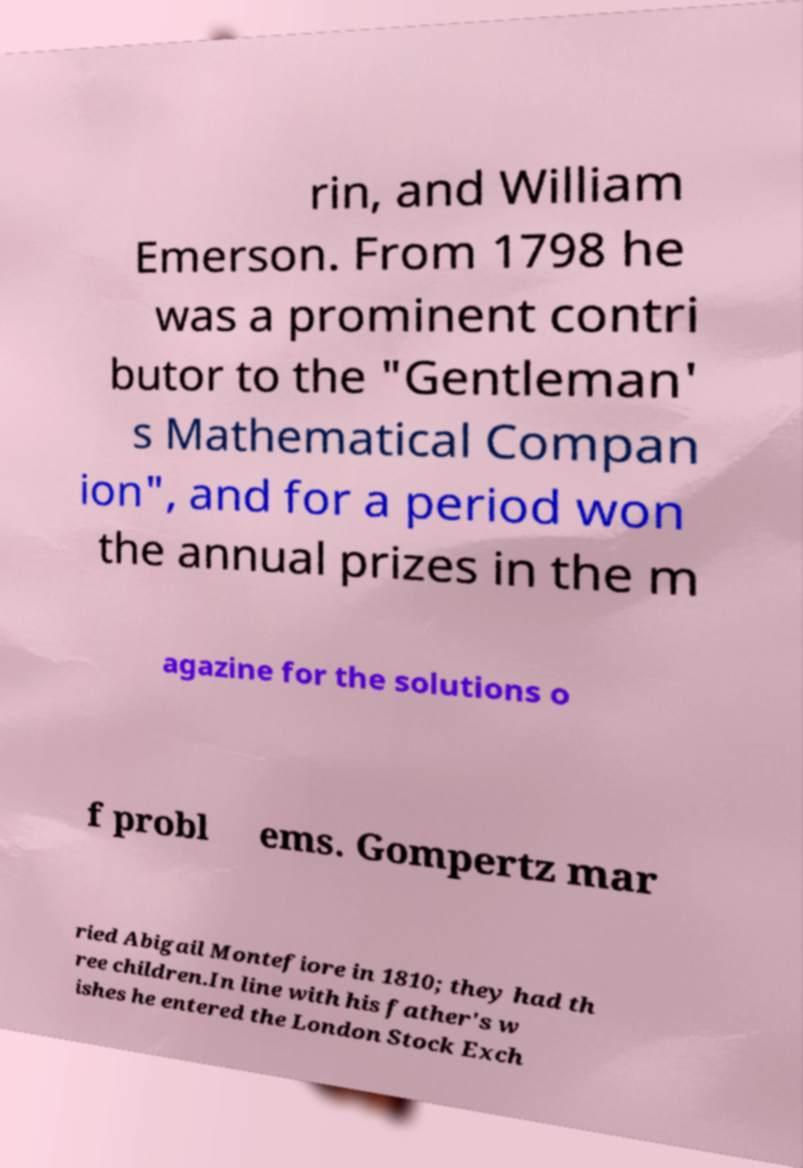Could you extract and type out the text from this image? rin, and William Emerson. From 1798 he was a prominent contri butor to the "Gentleman' s Mathematical Compan ion", and for a period won the annual prizes in the m agazine for the solutions o f probl ems. Gompertz mar ried Abigail Montefiore in 1810; they had th ree children.In line with his father's w ishes he entered the London Stock Exch 